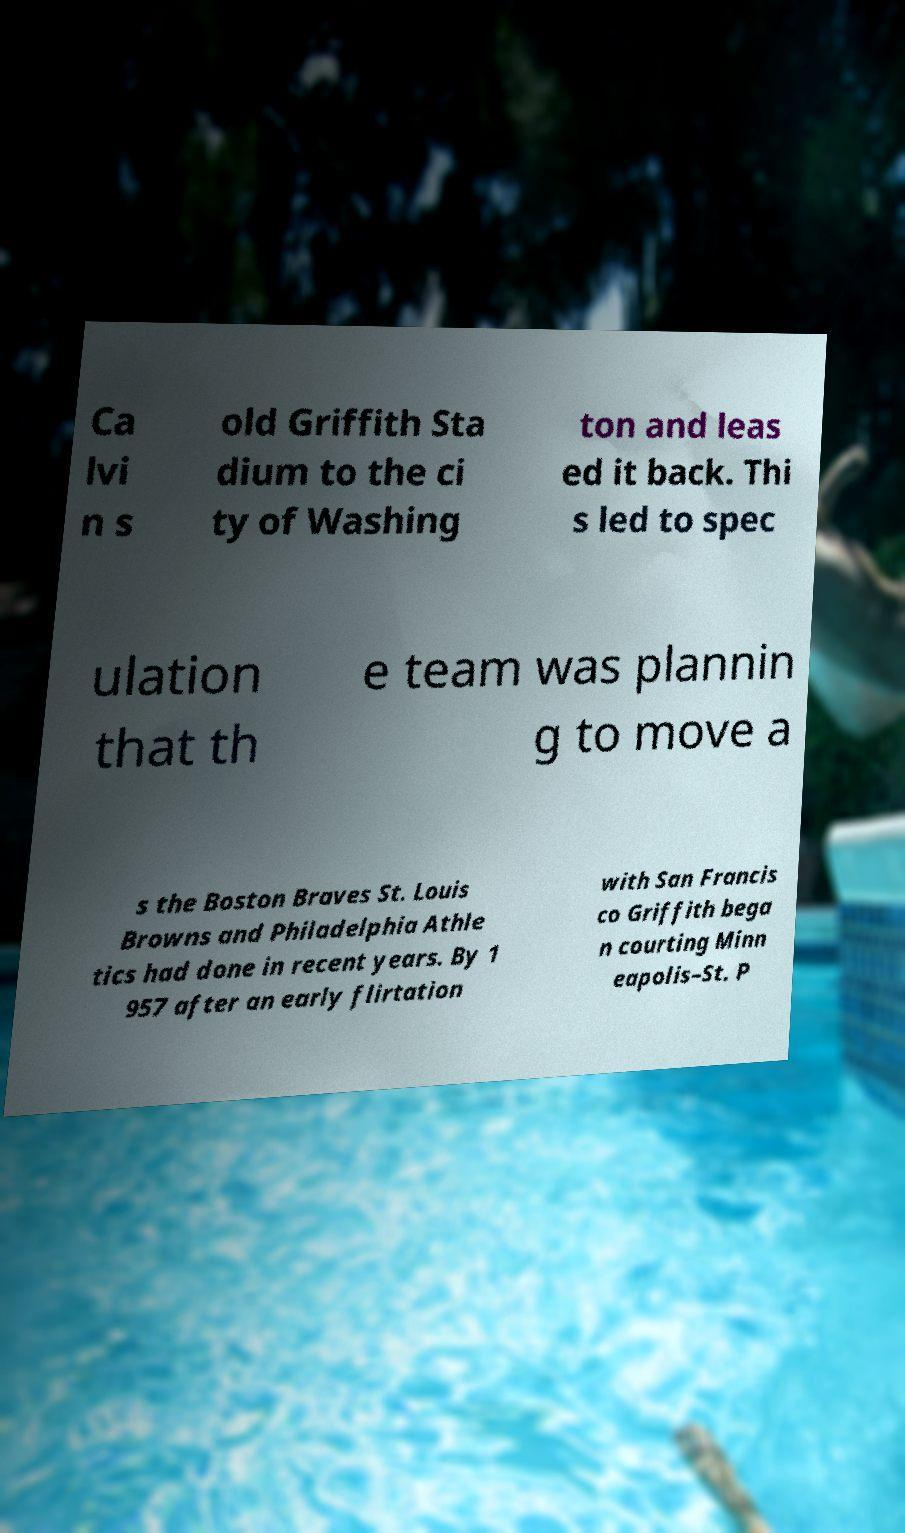What messages or text are displayed in this image? I need them in a readable, typed format. Ca lvi n s old Griffith Sta dium to the ci ty of Washing ton and leas ed it back. Thi s led to spec ulation that th e team was plannin g to move a s the Boston Braves St. Louis Browns and Philadelphia Athle tics had done in recent years. By 1 957 after an early flirtation with San Francis co Griffith bega n courting Minn eapolis–St. P 